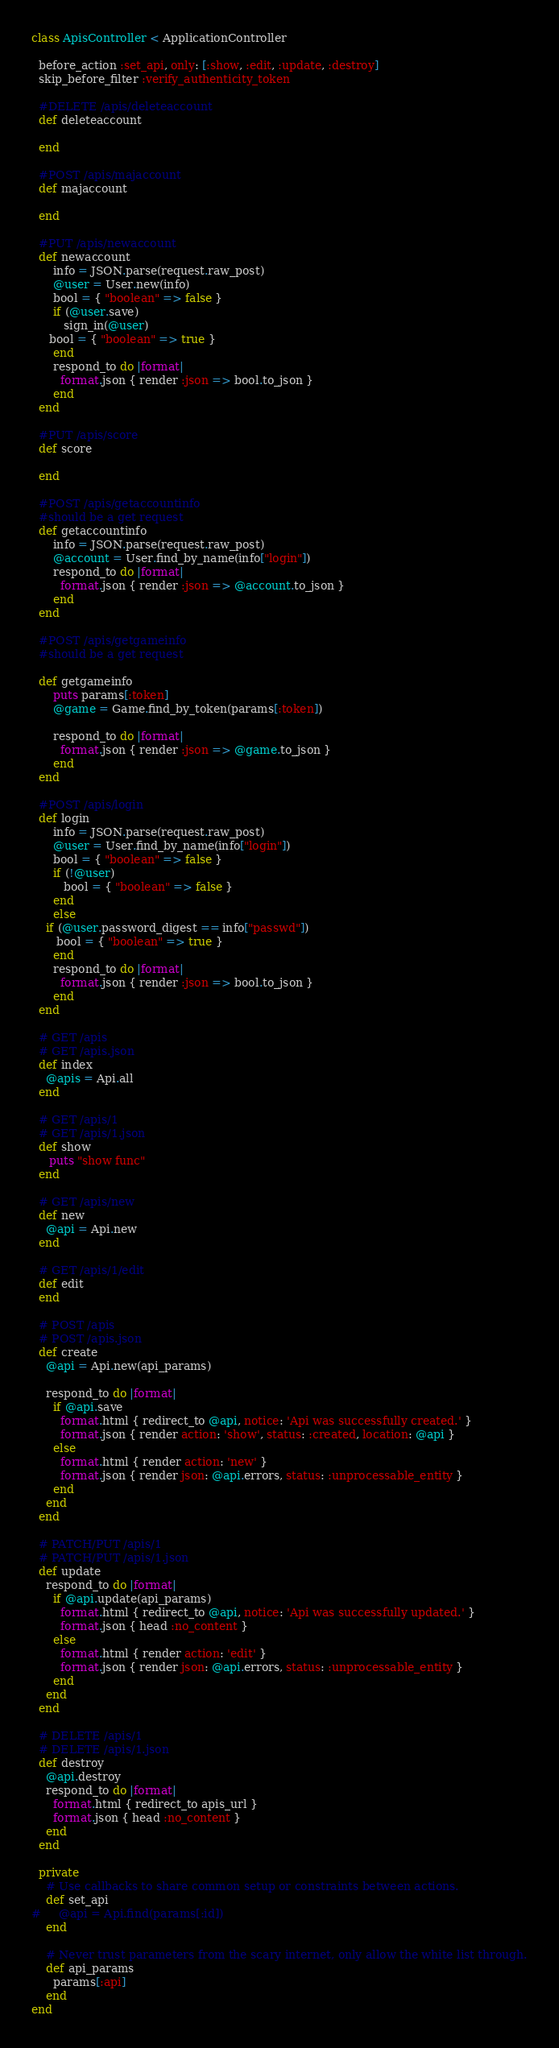Convert code to text. <code><loc_0><loc_0><loc_500><loc_500><_Ruby_>class ApisController < ApplicationController
  
  before_action :set_api, only: [:show, :edit, :update, :destroy]
  skip_before_filter :verify_authenticity_token

  #DELETE /apis/deleteaccount
  def deleteaccount

  end

  #POST /apis/majaccount
  def majaccount

  end

  #PUT /apis/newaccount
  def newaccount
      info = JSON.parse(request.raw_post)
      @user = User.new(info)
      bool = { "boolean" => false }
      if (@user.save)
      	 sign_in(@user)
	 bool = { "boolean" => true }
      end
      respond_to do |format|
      	format.json { render :json => bool.to_json }
      end
  end

  #PUT /apis/score
  def score
      
  end

  #POST /apis/getaccountinfo
  #should be a get request
  def getaccountinfo
      info = JSON.parse(request.raw_post)
      @account = User.find_by_name(info["login"])
      respond_to do |format|
      	format.json { render :json => @account.to_json }
      end      
  end

  #POST /apis/getgameinfo
  #should be a get request

  def getgameinfo
      puts params[:token]
      @game = Game.find_by_token(params[:token])

      respond_to do |format|
      	format.json { render :json => @game.to_json }
      end
  end

  #POST /apis/login
  def login
      info = JSON.parse(request.raw_post)
      @user = User.find_by_name(info["login"])
      bool = { "boolean" => false }
      if (!@user)
      	 bool = { "boolean" => false }
      end
      else
	if (@user.password_digest == info["passwd"])
	   bool = { "boolean" => true }
      end
      respond_to do |format|
      	format.json { render :json => bool.to_json }
      end
  end

  # GET /apis
  # GET /apis.json
  def index
    @apis = Api.all
  end

  # GET /apis/1
  # GET /apis/1.json
  def show
     puts "show func"
  end

  # GET /apis/new
  def new
    @api = Api.new
  end

  # GET /apis/1/edit
  def edit
  end

  # POST /apis
  # POST /apis.json
  def create
    @api = Api.new(api_params)

    respond_to do |format|
      if @api.save
        format.html { redirect_to @api, notice: 'Api was successfully created.' }
        format.json { render action: 'show', status: :created, location: @api }
      else
        format.html { render action: 'new' }
        format.json { render json: @api.errors, status: :unprocessable_entity }
      end
    end
  end

  # PATCH/PUT /apis/1
  # PATCH/PUT /apis/1.json
  def update
    respond_to do |format|
      if @api.update(api_params)
        format.html { redirect_to @api, notice: 'Api was successfully updated.' }
        format.json { head :no_content }
      else
        format.html { render action: 'edit' }
        format.json { render json: @api.errors, status: :unprocessable_entity }
      end
    end
  end

  # DELETE /apis/1
  # DELETE /apis/1.json
  def destroy
    @api.destroy
    respond_to do |format|
      format.html { redirect_to apis_url }
      format.json { head :no_content }
    end
  end

  private
    # Use callbacks to share common setup or constraints between actions.
    def set_api
#     @api = Api.find(params[:id])
    end

    # Never trust parameters from the scary internet, only allow the white list through.
    def api_params
      params[:api]
    end
end
</code> 